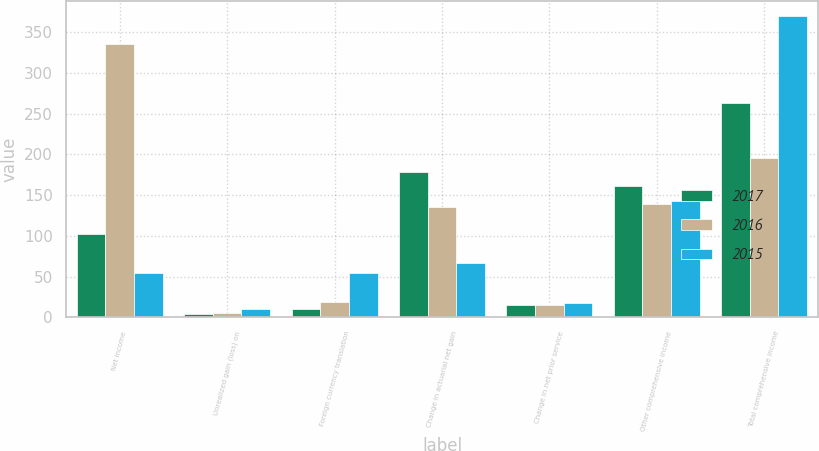Convert chart. <chart><loc_0><loc_0><loc_500><loc_500><stacked_bar_chart><ecel><fcel>Net income<fcel>Unrealized gain (loss) on<fcel>Foreign currency translation<fcel>Change in actuarial net gain<fcel>Change in net prior service<fcel>Other comprehensive income<fcel>Total comprehensive income<nl><fcel>2017<fcel>102<fcel>4<fcel>10<fcel>178<fcel>15<fcel>161<fcel>263<nl><fcel>2016<fcel>335<fcel>5<fcel>19<fcel>135<fcel>15<fcel>139<fcel>196<nl><fcel>2015<fcel>54<fcel>10<fcel>54<fcel>67<fcel>18<fcel>143<fcel>370<nl></chart> 